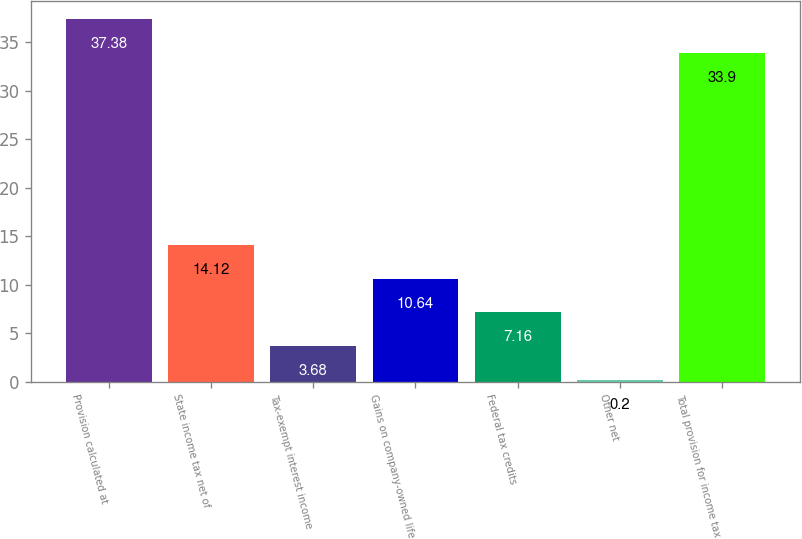Convert chart. <chart><loc_0><loc_0><loc_500><loc_500><bar_chart><fcel>Provision calculated at<fcel>State income tax net of<fcel>Tax-exempt interest income<fcel>Gains on company-owned life<fcel>Federal tax credits<fcel>Other net<fcel>Total provision for income tax<nl><fcel>37.38<fcel>14.12<fcel>3.68<fcel>10.64<fcel>7.16<fcel>0.2<fcel>33.9<nl></chart> 